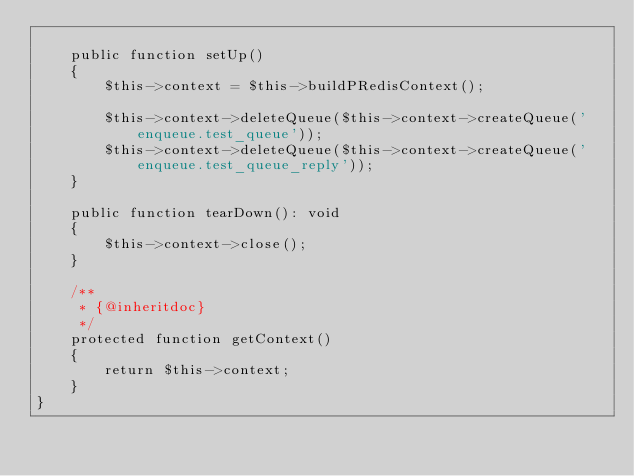<code> <loc_0><loc_0><loc_500><loc_500><_PHP_>
    public function setUp()
    {
        $this->context = $this->buildPRedisContext();

        $this->context->deleteQueue($this->context->createQueue('enqueue.test_queue'));
        $this->context->deleteQueue($this->context->createQueue('enqueue.test_queue_reply'));
    }

    public function tearDown(): void
    {
        $this->context->close();
    }

    /**
     * {@inheritdoc}
     */
    protected function getContext()
    {
        return $this->context;
    }
}
</code> 